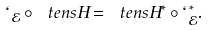<formula> <loc_0><loc_0><loc_500><loc_500>\ell _ { \mathcal { E } } \circ \ t e n s { H } = \ t e n s { H } ^ { * } \circ \ell _ { \mathcal { E } } ^ { * } .</formula> 